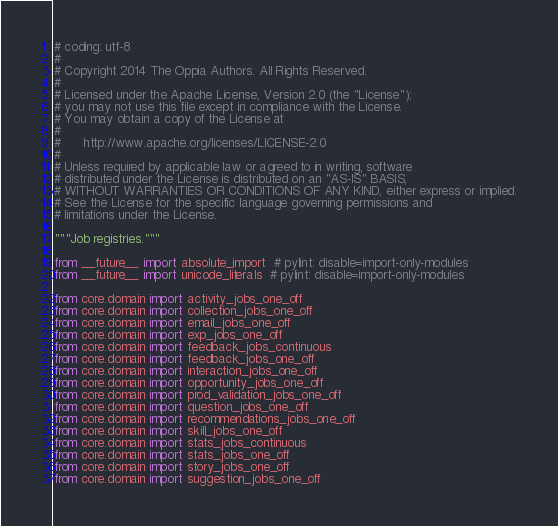<code> <loc_0><loc_0><loc_500><loc_500><_Python_># coding: utf-8
#
# Copyright 2014 The Oppia Authors. All Rights Reserved.
#
# Licensed under the Apache License, Version 2.0 (the "License");
# you may not use this file except in compliance with the License.
# You may obtain a copy of the License at
#
#      http://www.apache.org/licenses/LICENSE-2.0
#
# Unless required by applicable law or agreed to in writing, software
# distributed under the License is distributed on an "AS-IS" BASIS,
# WITHOUT WARRANTIES OR CONDITIONS OF ANY KIND, either express or implied.
# See the License for the specific language governing permissions and
# limitations under the License.

"""Job registries."""

from __future__ import absolute_import  # pylint: disable=import-only-modules
from __future__ import unicode_literals  # pylint: disable=import-only-modules

from core.domain import activity_jobs_one_off
from core.domain import collection_jobs_one_off
from core.domain import email_jobs_one_off
from core.domain import exp_jobs_one_off
from core.domain import feedback_jobs_continuous
from core.domain import feedback_jobs_one_off
from core.domain import interaction_jobs_one_off
from core.domain import opportunity_jobs_one_off
from core.domain import prod_validation_jobs_one_off
from core.domain import question_jobs_one_off
from core.domain import recommendations_jobs_one_off
from core.domain import skill_jobs_one_off
from core.domain import stats_jobs_continuous
from core.domain import stats_jobs_one_off
from core.domain import story_jobs_one_off
from core.domain import suggestion_jobs_one_off</code> 